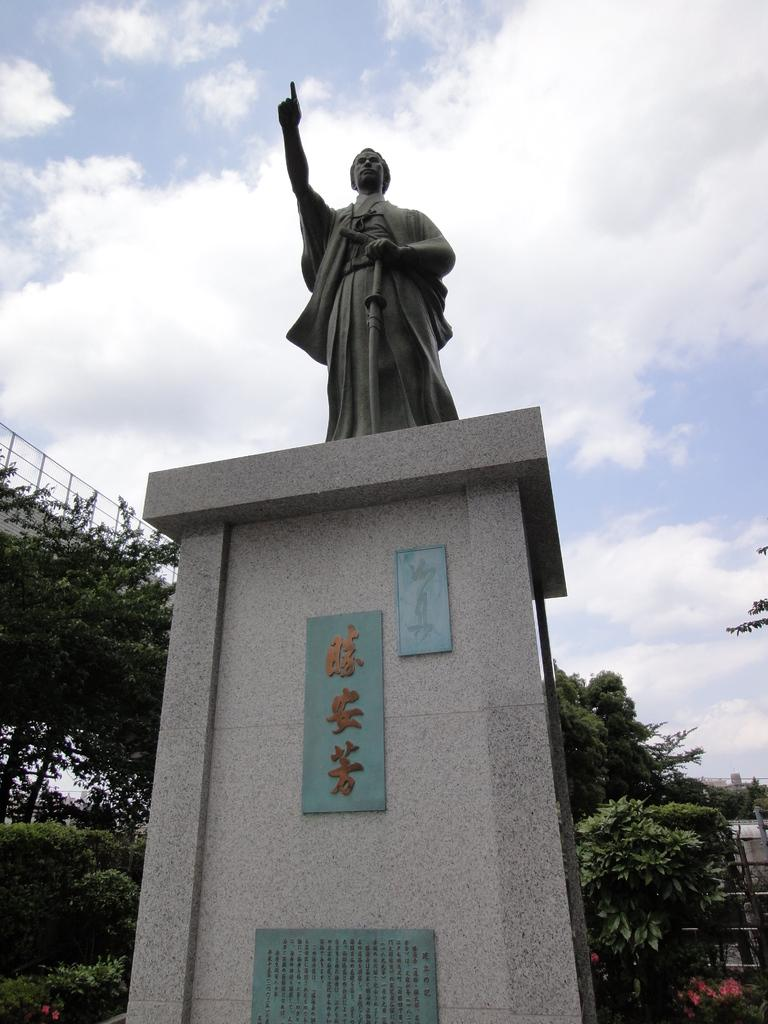What is the main subject of the image? There is a statue in the image. How is the statue positioned in the image? The statue is on a pedestal. What type of vegetation can be seen in the image? There are bushes, shrubs, and trees in the image. What is visible in the background of the image? The sky is visible in the image, and clouds are present in the sky. What type of barrier is present in the image? There is an iron grill in the image. What type of berry is growing on the statue in the image? There are no berries present on the statue in the image. What season is depicted in the image? The image does not indicate a specific season, as there are no seasonal elements or clues provided. 